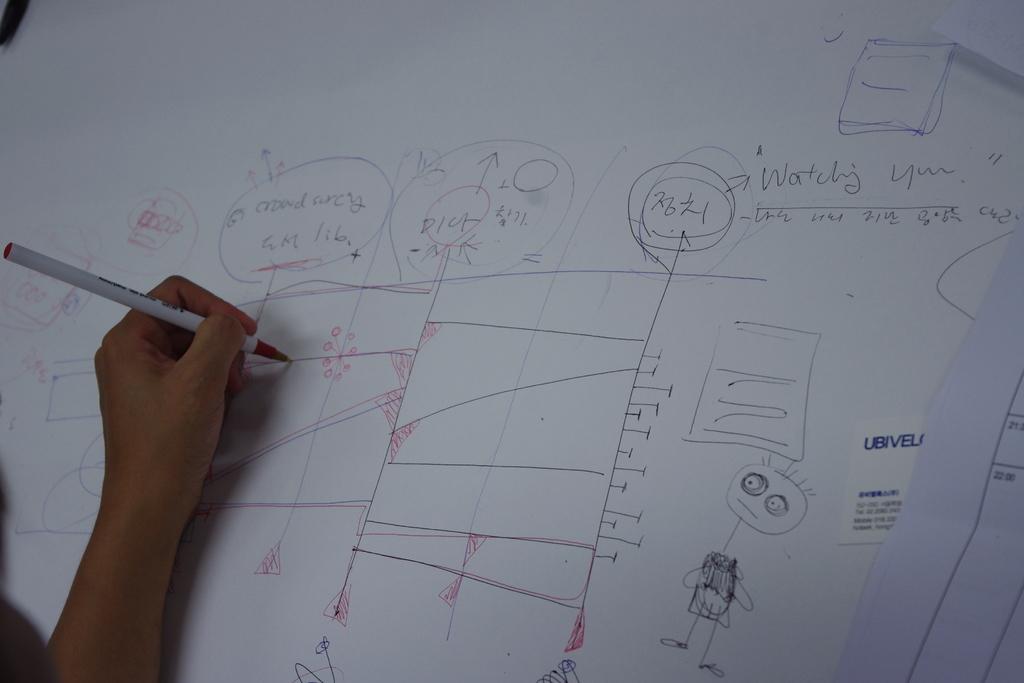What is the word in blue on the card?
Give a very brief answer. Ubivel. 